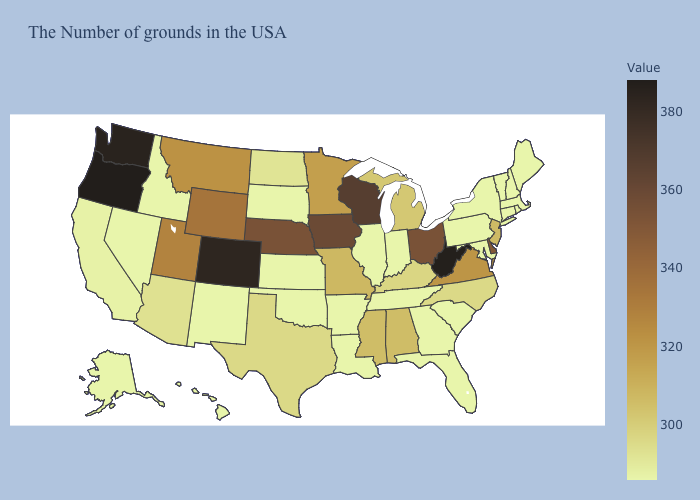Among the states that border Montana , does Wyoming have the highest value?
Write a very short answer. Yes. Among the states that border Kansas , does Missouri have the highest value?
Write a very short answer. No. Does Tennessee have the lowest value in the South?
Give a very brief answer. Yes. Among the states that border Missouri , does Illinois have the highest value?
Short answer required. No. Among the states that border South Dakota , does Iowa have the highest value?
Be succinct. Yes. 